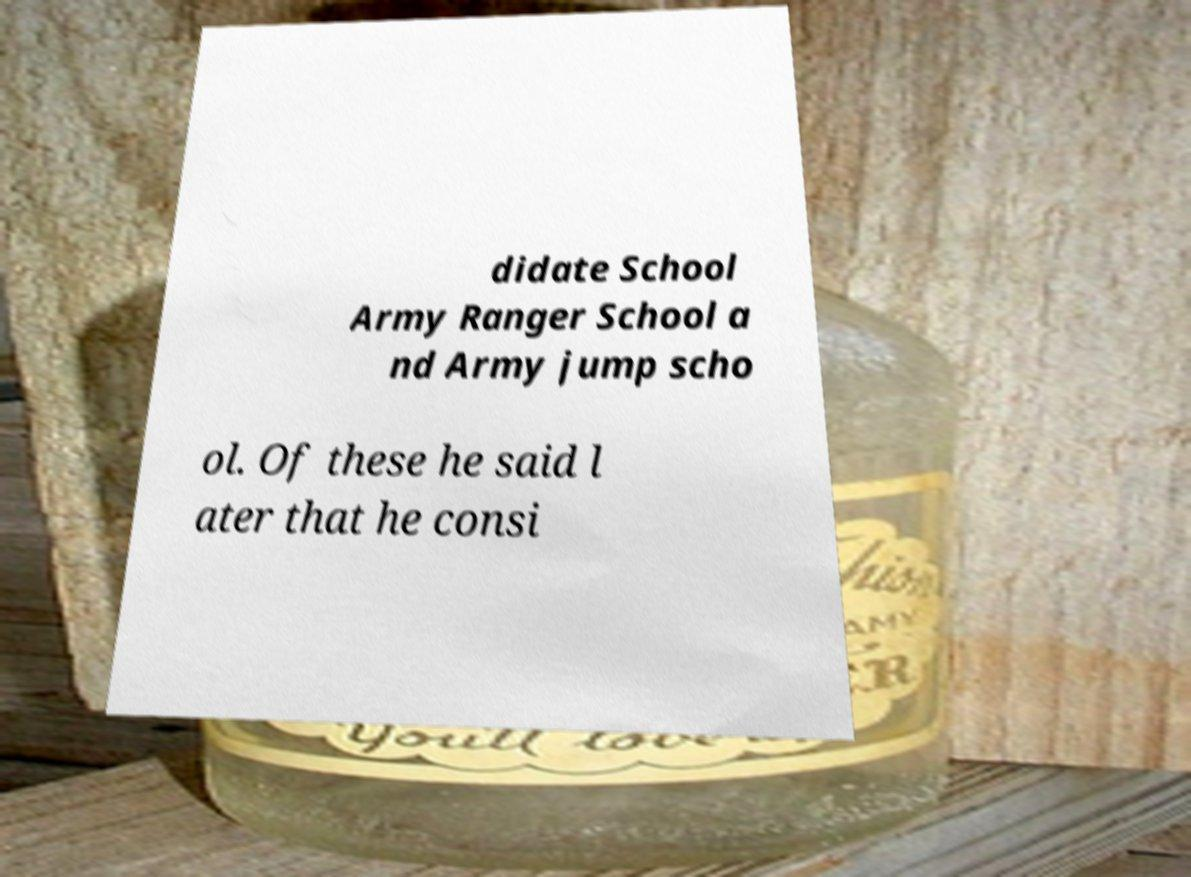Could you extract and type out the text from this image? didate School Army Ranger School a nd Army jump scho ol. Of these he said l ater that he consi 